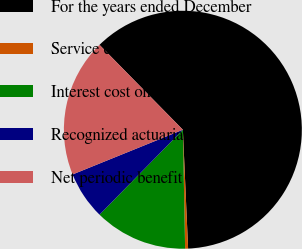Convert chart. <chart><loc_0><loc_0><loc_500><loc_500><pie_chart><fcel>For the years ended December<fcel>Service cost - benefits earned<fcel>Interest cost on projected<fcel>Recognized actuarial loss<fcel>Net periodic benefit cost<nl><fcel>61.65%<fcel>0.4%<fcel>12.65%<fcel>6.52%<fcel>18.77%<nl></chart> 